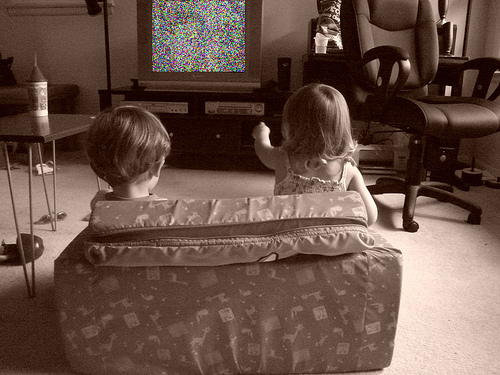Describe the room in which the kids are watching TV. The room appears to be a family living area, equipped with a large chair, an entertainment system housing various devices and decorations including a trophy and multiple photographs. The ambiance suggests a comfortable, lived-in space typical for family activities. 